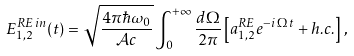Convert formula to latex. <formula><loc_0><loc_0><loc_500><loc_500>E ^ { R E \, i n } _ { 1 , 2 } ( t ) = \sqrt { \frac { 4 \pi \hbar { \omega } _ { 0 } } { { \mathcal { A } } c } } \int _ { 0 } ^ { + \infty } \frac { d \Omega } { 2 \pi } \left [ a ^ { R E } _ { 1 , 2 } e ^ { - i \, \Omega \, t } + h . c . \right ] \, ,</formula> 